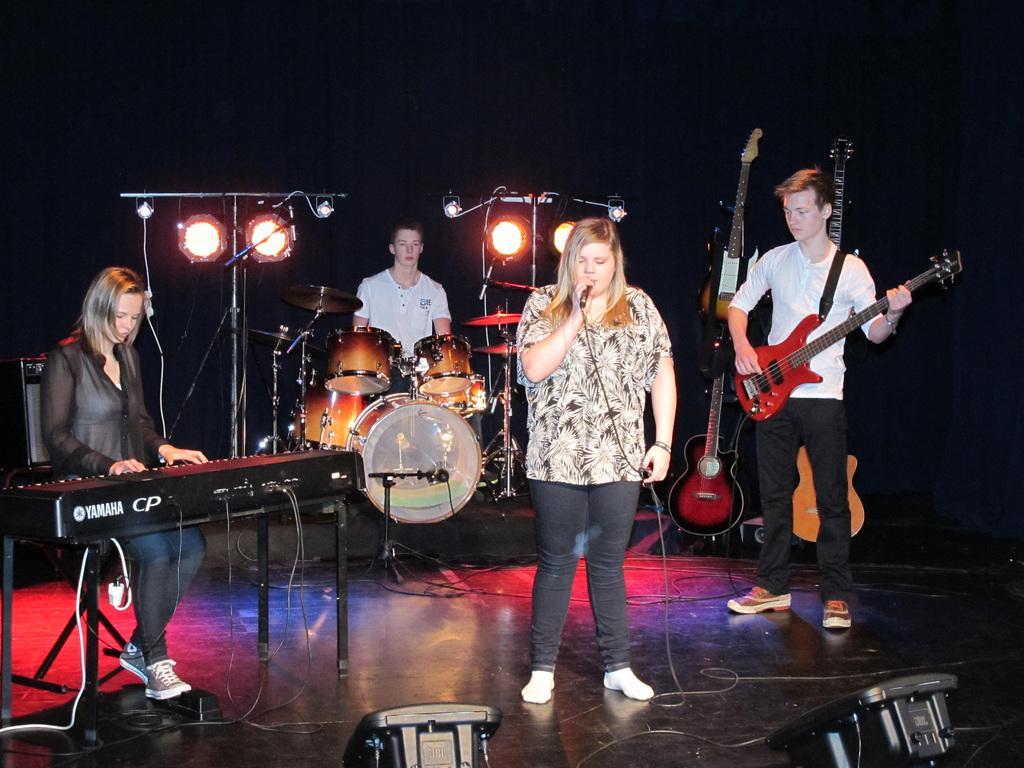Could you give a brief overview of what you see in this image? In this image, There are some people standing and holding the music instruments and in the left side there is a piano which is in black color and in the background there is a man who is playing the music drums. 